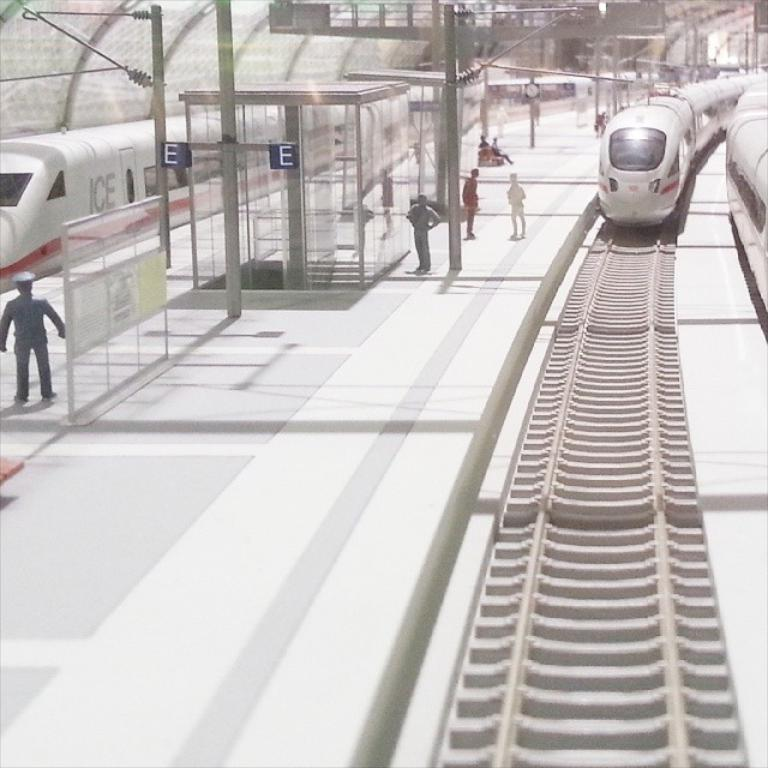<image>
Write a terse but informative summary of the picture. A train that is at a station and has ICE written on the side of it. 